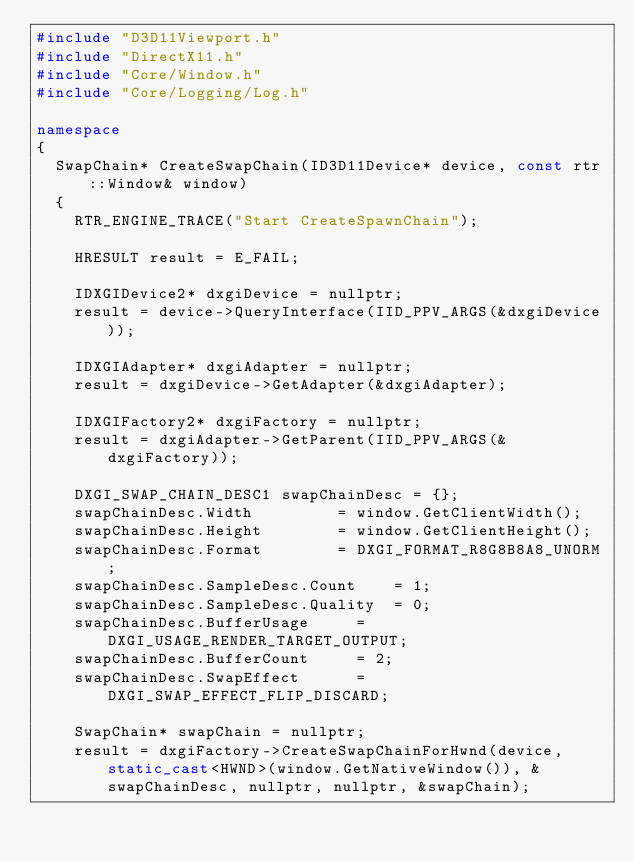<code> <loc_0><loc_0><loc_500><loc_500><_C++_>#include "D3D11Viewport.h"
#include "DirectX11.h"
#include "Core/Window.h"
#include "Core/Logging/Log.h"

namespace
{
	SwapChain* CreateSwapChain(ID3D11Device* device, const rtr::Window& window)
	{
		RTR_ENGINE_TRACE("Start CreateSpawnChain");

		HRESULT result = E_FAIL;

		IDXGIDevice2* dxgiDevice = nullptr;
		result = device->QueryInterface(IID_PPV_ARGS(&dxgiDevice));

		IDXGIAdapter* dxgiAdapter = nullptr;
		result = dxgiDevice->GetAdapter(&dxgiAdapter);

		IDXGIFactory2* dxgiFactory = nullptr;
		result = dxgiAdapter->GetParent(IID_PPV_ARGS(&dxgiFactory));

		DXGI_SWAP_CHAIN_DESC1 swapChainDesc = {};
		swapChainDesc.Width					= window.GetClientWidth();
		swapChainDesc.Height				= window.GetClientHeight();
		swapChainDesc.Format				= DXGI_FORMAT_R8G8B8A8_UNORM;
		swapChainDesc.SampleDesc.Count		= 1;
		swapChainDesc.SampleDesc.Quality	= 0;
		swapChainDesc.BufferUsage			= DXGI_USAGE_RENDER_TARGET_OUTPUT;
		swapChainDesc.BufferCount			= 2;
		swapChainDesc.SwapEffect			= DXGI_SWAP_EFFECT_FLIP_DISCARD;

		SwapChain* swapChain = nullptr;
		result = dxgiFactory->CreateSwapChainForHwnd(device, static_cast<HWND>(window.GetNativeWindow()), &swapChainDesc, nullptr, nullptr, &swapChain);
</code> 